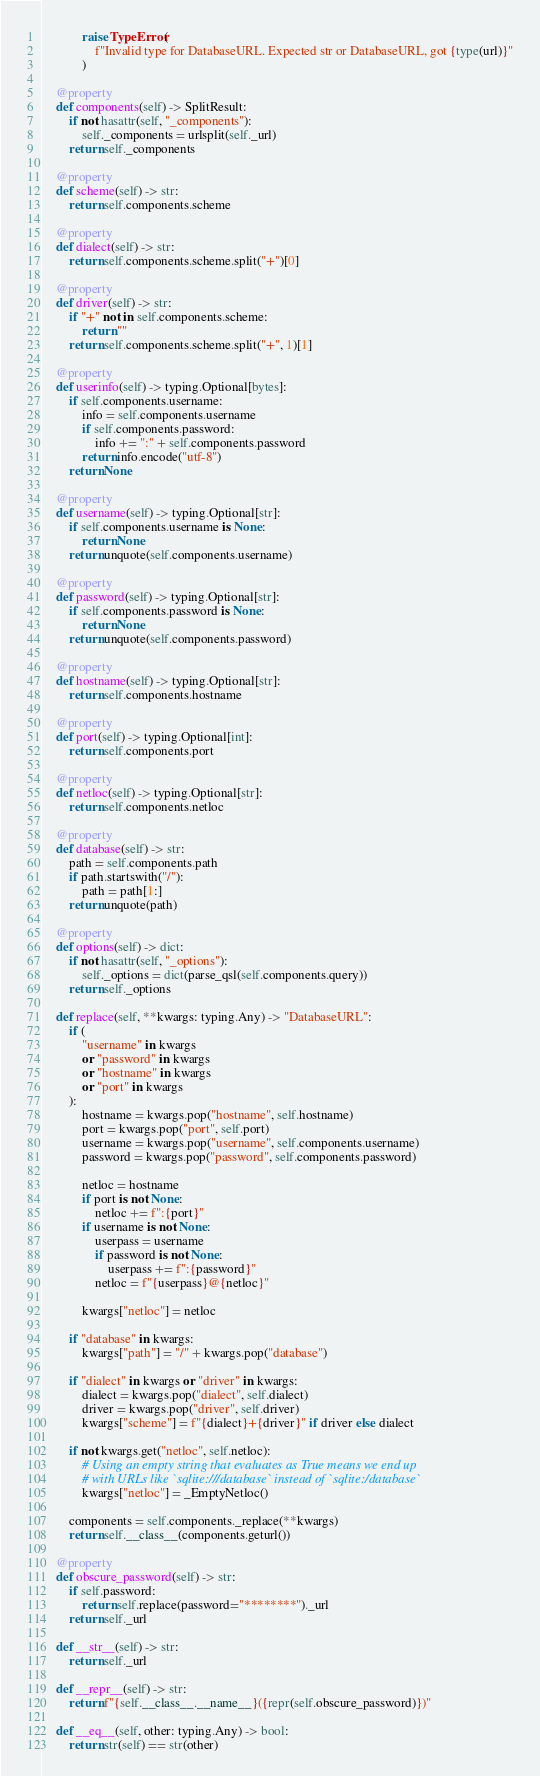Convert code to text. <code><loc_0><loc_0><loc_500><loc_500><_Python_>            raise TypeError(
                f"Invalid type for DatabaseURL. Expected str or DatabaseURL, got {type(url)}"
            )

    @property
    def components(self) -> SplitResult:
        if not hasattr(self, "_components"):
            self._components = urlsplit(self._url)
        return self._components

    @property
    def scheme(self) -> str:
        return self.components.scheme

    @property
    def dialect(self) -> str:
        return self.components.scheme.split("+")[0]

    @property
    def driver(self) -> str:
        if "+" not in self.components.scheme:
            return ""
        return self.components.scheme.split("+", 1)[1]

    @property
    def userinfo(self) -> typing.Optional[bytes]:
        if self.components.username:
            info = self.components.username
            if self.components.password:
                info += ":" + self.components.password
            return info.encode("utf-8")
        return None

    @property
    def username(self) -> typing.Optional[str]:
        if self.components.username is None:
            return None
        return unquote(self.components.username)

    @property
    def password(self) -> typing.Optional[str]:
        if self.components.password is None:
            return None
        return unquote(self.components.password)

    @property
    def hostname(self) -> typing.Optional[str]:
        return self.components.hostname

    @property
    def port(self) -> typing.Optional[int]:
        return self.components.port

    @property
    def netloc(self) -> typing.Optional[str]:
        return self.components.netloc

    @property
    def database(self) -> str:
        path = self.components.path
        if path.startswith("/"):
            path = path[1:]
        return unquote(path)

    @property
    def options(self) -> dict:
        if not hasattr(self, "_options"):
            self._options = dict(parse_qsl(self.components.query))
        return self._options

    def replace(self, **kwargs: typing.Any) -> "DatabaseURL":
        if (
            "username" in kwargs
            or "password" in kwargs
            or "hostname" in kwargs
            or "port" in kwargs
        ):
            hostname = kwargs.pop("hostname", self.hostname)
            port = kwargs.pop("port", self.port)
            username = kwargs.pop("username", self.components.username)
            password = kwargs.pop("password", self.components.password)

            netloc = hostname
            if port is not None:
                netloc += f":{port}"
            if username is not None:
                userpass = username
                if password is not None:
                    userpass += f":{password}"
                netloc = f"{userpass}@{netloc}"

            kwargs["netloc"] = netloc

        if "database" in kwargs:
            kwargs["path"] = "/" + kwargs.pop("database")

        if "dialect" in kwargs or "driver" in kwargs:
            dialect = kwargs.pop("dialect", self.dialect)
            driver = kwargs.pop("driver", self.driver)
            kwargs["scheme"] = f"{dialect}+{driver}" if driver else dialect

        if not kwargs.get("netloc", self.netloc):
            # Using an empty string that evaluates as True means we end up
            # with URLs like `sqlite:///database` instead of `sqlite:/database`
            kwargs["netloc"] = _EmptyNetloc()

        components = self.components._replace(**kwargs)
        return self.__class__(components.geturl())

    @property
    def obscure_password(self) -> str:
        if self.password:
            return self.replace(password="********")._url
        return self._url

    def __str__(self) -> str:
        return self._url

    def __repr__(self) -> str:
        return f"{self.__class__.__name__}({repr(self.obscure_password)})"

    def __eq__(self, other: typing.Any) -> bool:
        return str(self) == str(other)
</code> 